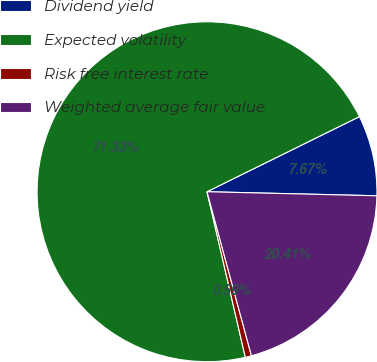Convert chart. <chart><loc_0><loc_0><loc_500><loc_500><pie_chart><fcel>Dividend yield<fcel>Expected volatility<fcel>Risk free interest rate<fcel>Weighted average fair value<nl><fcel>7.67%<fcel>71.33%<fcel>0.59%<fcel>20.41%<nl></chart> 